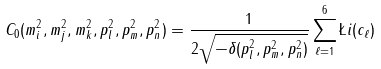Convert formula to latex. <formula><loc_0><loc_0><loc_500><loc_500>C _ { 0 } ( m _ { i } ^ { 2 } , m _ { j } ^ { 2 } , m _ { k } ^ { 2 } , p _ { l } ^ { 2 } , p _ { m } ^ { 2 } , p _ { n } ^ { 2 } ) = \frac { 1 } { 2 \sqrt { - \delta ( p _ { l } ^ { 2 } , p _ { m } ^ { 2 } , p _ { n } ^ { 2 } ) } } \sum _ { \ell = 1 } ^ { 6 } \L i ( c _ { \ell } )</formula> 